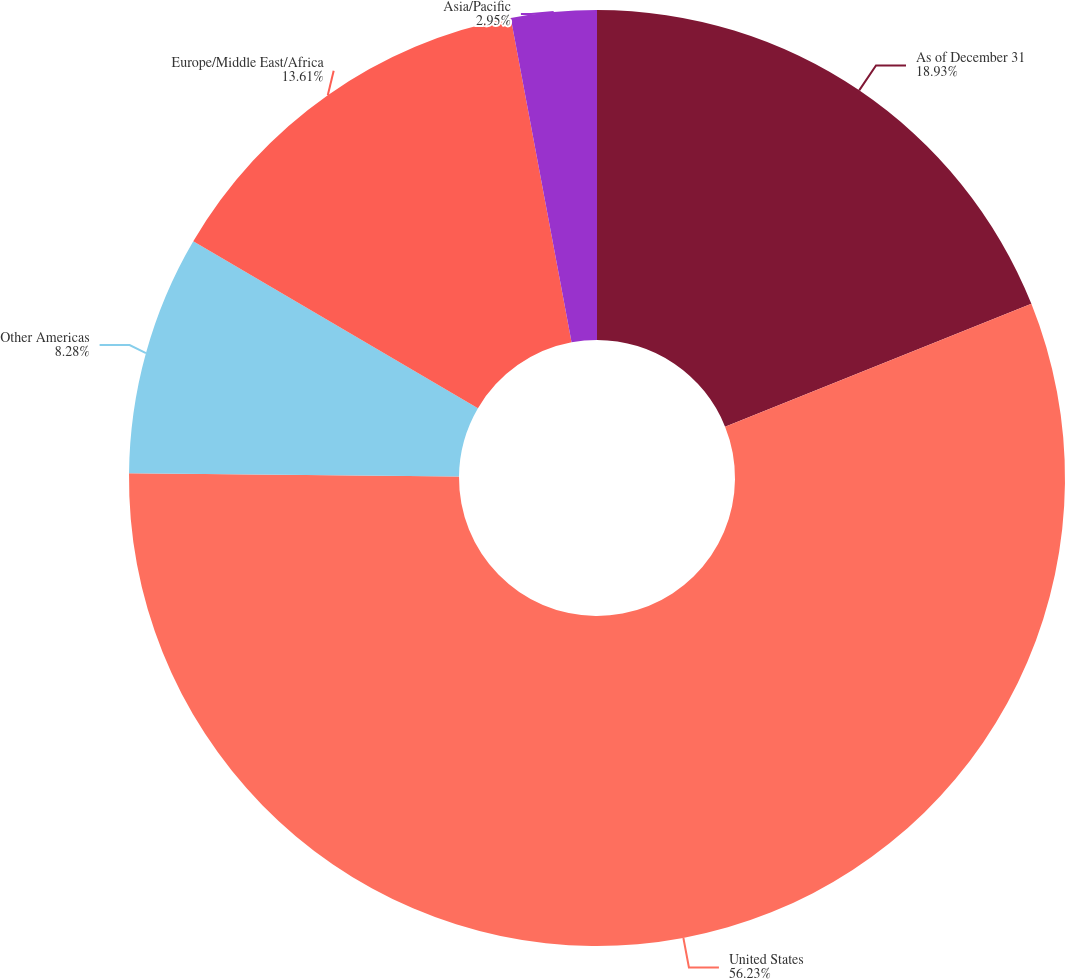Convert chart to OTSL. <chart><loc_0><loc_0><loc_500><loc_500><pie_chart><fcel>As of December 31<fcel>United States<fcel>Other Americas<fcel>Europe/Middle East/Africa<fcel>Asia/Pacific<nl><fcel>18.93%<fcel>56.23%<fcel>8.28%<fcel>13.61%<fcel>2.95%<nl></chart> 